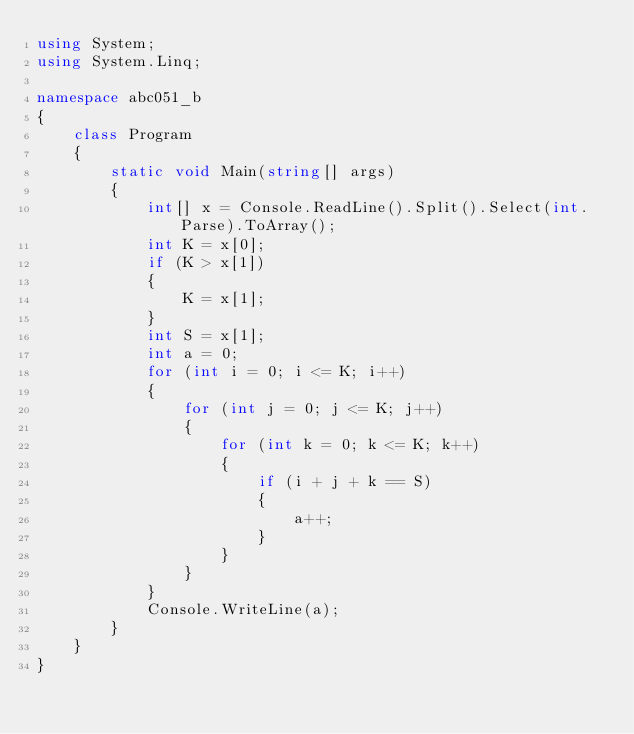<code> <loc_0><loc_0><loc_500><loc_500><_C#_>using System;
using System.Linq;

namespace abc051_b
{
    class Program
    {
        static void Main(string[] args)
        {
            int[] x = Console.ReadLine().Split().Select(int.Parse).ToArray();
            int K = x[0];
            if (K > x[1])
            {
                K = x[1];
            }
            int S = x[1];
            int a = 0;
            for (int i = 0; i <= K; i++)
            {
                for (int j = 0; j <= K; j++)
                {
                    for (int k = 0; k <= K; k++)
                    {
                        if (i + j + k == S)
                        {
                            a++;
                        }
                    }
                }
            }
            Console.WriteLine(a);
        }
    }
}</code> 